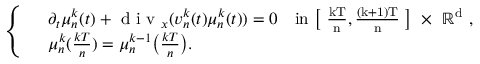<formula> <loc_0><loc_0><loc_500><loc_500>\left \{ \begin{array} { r l } & { \partial _ { t } \mu _ { n } ^ { k } ( t ) + d i v _ { x } ( v _ { n } ^ { k } ( t ) \mu _ { n } ^ { k } ( t ) ) = 0 \quad i n \left [ \frac { k T } { n } , \frac { ( k + 1 ) T } { n } \right ] \times \mathbb { R } ^ { d } , } \\ & { \mu _ { n } ^ { k } ( \frac { k T } { n } ) = \mu _ { n } ^ { k - 1 } \left ( \frac { k T } { n } \right ) . } \end{array}</formula> 